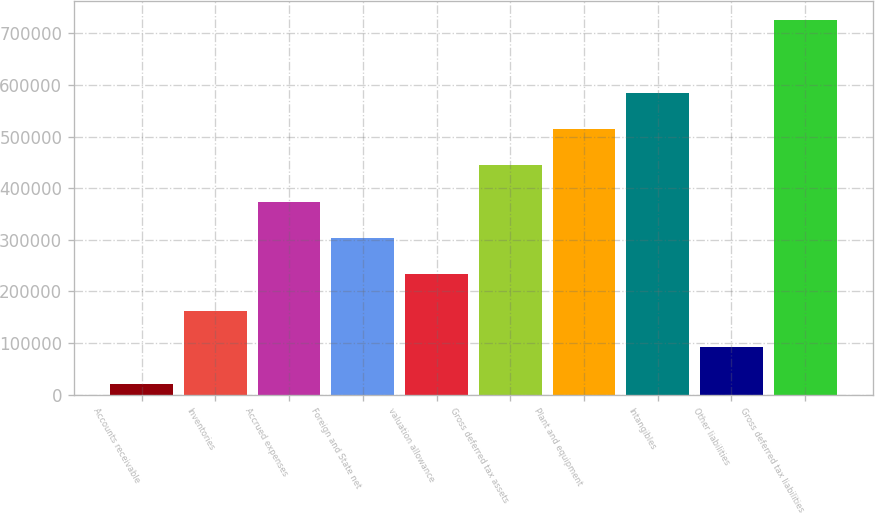Convert chart to OTSL. <chart><loc_0><loc_0><loc_500><loc_500><bar_chart><fcel>Accounts receivable<fcel>Inventories<fcel>Accrued expenses<fcel>Foreign and State net<fcel>valuation allowance<fcel>Gross deferred tax assets<fcel>Plant and equipment<fcel>Intangibles<fcel>Other liabilities<fcel>Gross deferred tax liabilities<nl><fcel>21756<fcel>162535<fcel>373702<fcel>303313<fcel>232924<fcel>444092<fcel>514481<fcel>584870<fcel>92145.3<fcel>725649<nl></chart> 